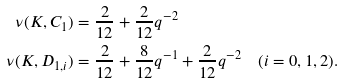Convert formula to latex. <formula><loc_0><loc_0><loc_500><loc_500>\nu ( K , C _ { 1 } ) & = \frac { 2 } { 1 2 } + \frac { 2 } { 1 2 } q ^ { - 2 } \\ \nu ( K , D _ { 1 , i } ) & = \frac { 2 } { 1 2 } + \frac { 8 } { 1 2 } q ^ { - 1 } + \frac { 2 } { 1 2 } q ^ { - 2 } \quad ( i = 0 , 1 , 2 ) .</formula> 